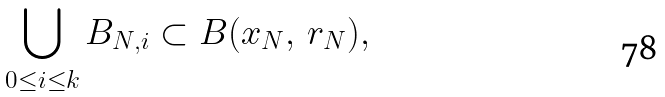Convert formula to latex. <formula><loc_0><loc_0><loc_500><loc_500>\bigcup _ { 0 \leq i \leq k } B _ { N , i } \subset B ( x _ { N } , \, r _ { N } ) ,</formula> 